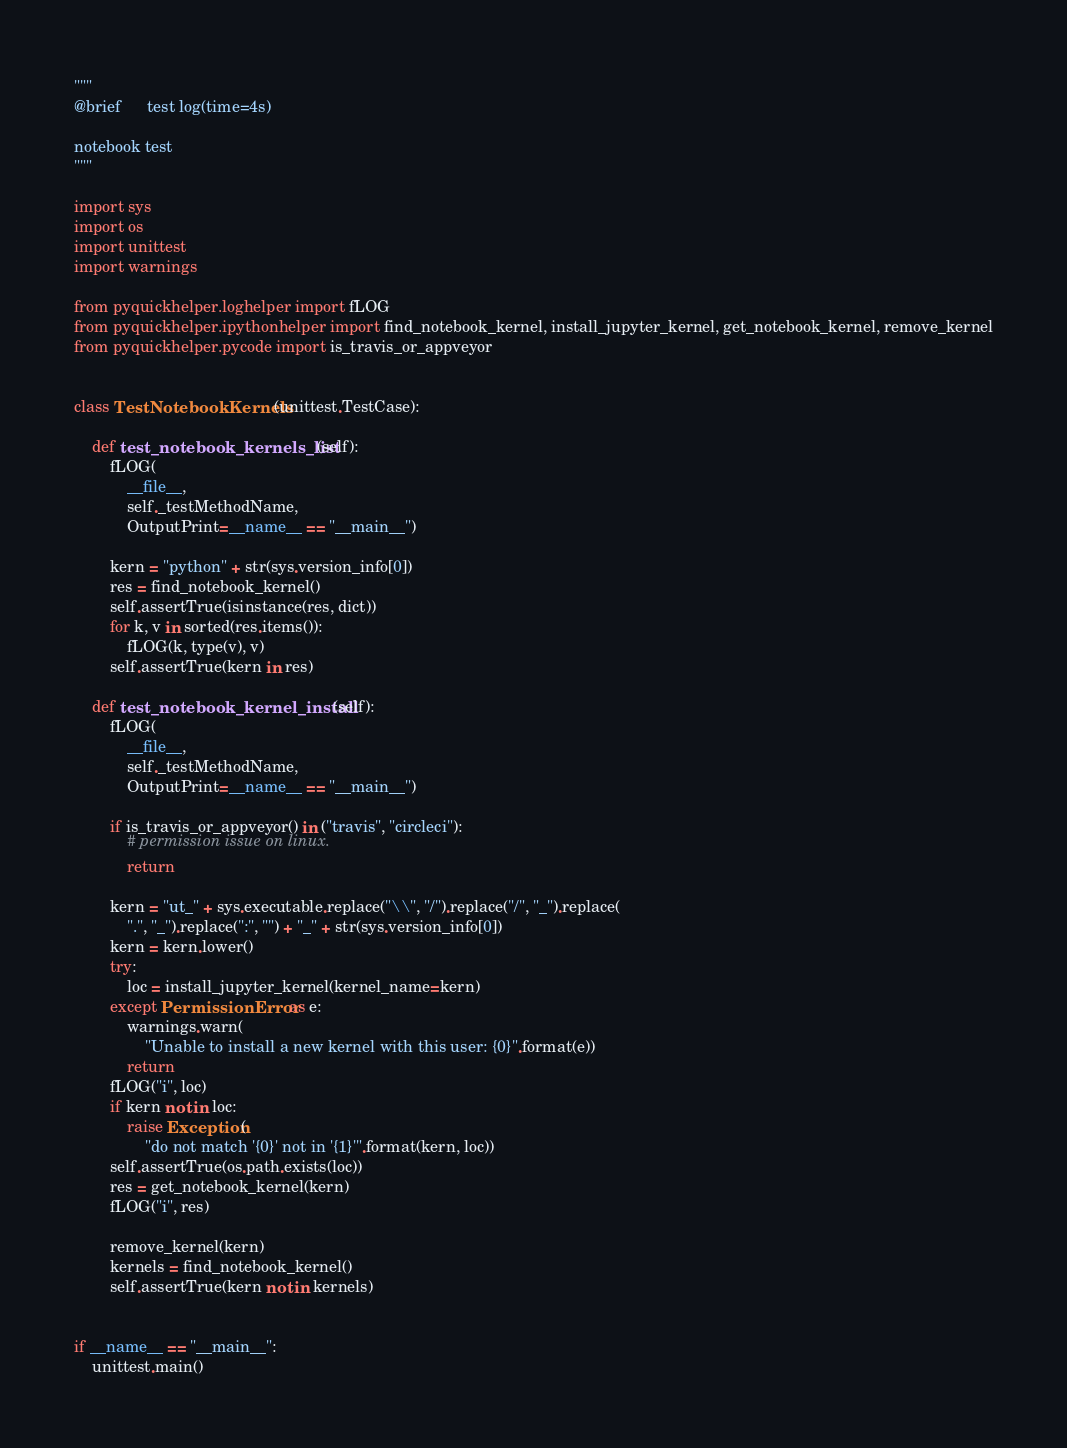Convert code to text. <code><loc_0><loc_0><loc_500><loc_500><_Python_>"""
@brief      test log(time=4s)

notebook test
"""

import sys
import os
import unittest
import warnings

from pyquickhelper.loghelper import fLOG
from pyquickhelper.ipythonhelper import find_notebook_kernel, install_jupyter_kernel, get_notebook_kernel, remove_kernel
from pyquickhelper.pycode import is_travis_or_appveyor


class TestNotebookKernels(unittest.TestCase):

    def test_notebook_kernels_list(self):
        fLOG(
            __file__,
            self._testMethodName,
            OutputPrint=__name__ == "__main__")

        kern = "python" + str(sys.version_info[0])
        res = find_notebook_kernel()
        self.assertTrue(isinstance(res, dict))
        for k, v in sorted(res.items()):
            fLOG(k, type(v), v)
        self.assertTrue(kern in res)

    def test_notebook_kernel_install(self):
        fLOG(
            __file__,
            self._testMethodName,
            OutputPrint=__name__ == "__main__")

        if is_travis_or_appveyor() in ("travis", "circleci"):
            # permission issue on linux.
            return

        kern = "ut_" + sys.executable.replace("\\", "/").replace("/", "_").replace(
            ".", "_").replace(":", "") + "_" + str(sys.version_info[0])
        kern = kern.lower()
        try:
            loc = install_jupyter_kernel(kernel_name=kern)
        except PermissionError as e:
            warnings.warn(
                "Unable to install a new kernel with this user: {0}".format(e))
            return
        fLOG("i", loc)
        if kern not in loc:
            raise Exception(
                "do not match '{0}' not in '{1}'".format(kern, loc))
        self.assertTrue(os.path.exists(loc))
        res = get_notebook_kernel(kern)
        fLOG("i", res)

        remove_kernel(kern)
        kernels = find_notebook_kernel()
        self.assertTrue(kern not in kernels)


if __name__ == "__main__":
    unittest.main()
</code> 